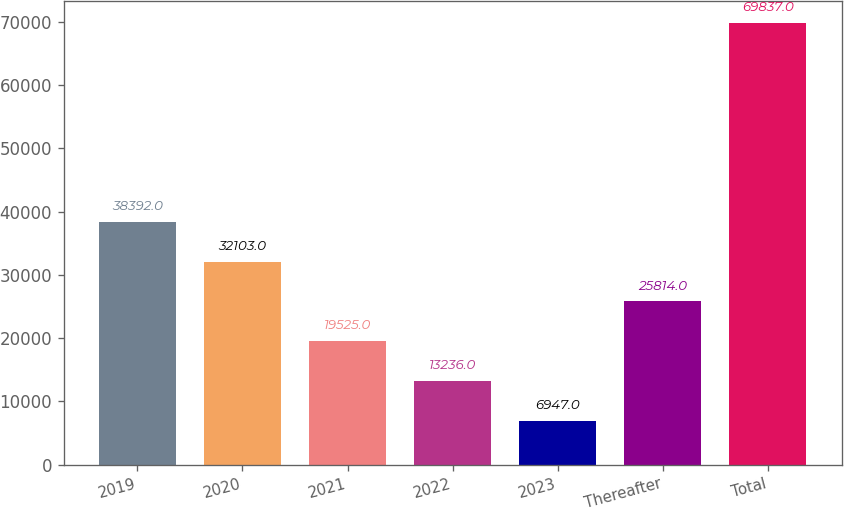Convert chart to OTSL. <chart><loc_0><loc_0><loc_500><loc_500><bar_chart><fcel>2019<fcel>2020<fcel>2021<fcel>2022<fcel>2023<fcel>Thereafter<fcel>Total<nl><fcel>38392<fcel>32103<fcel>19525<fcel>13236<fcel>6947<fcel>25814<fcel>69837<nl></chart> 